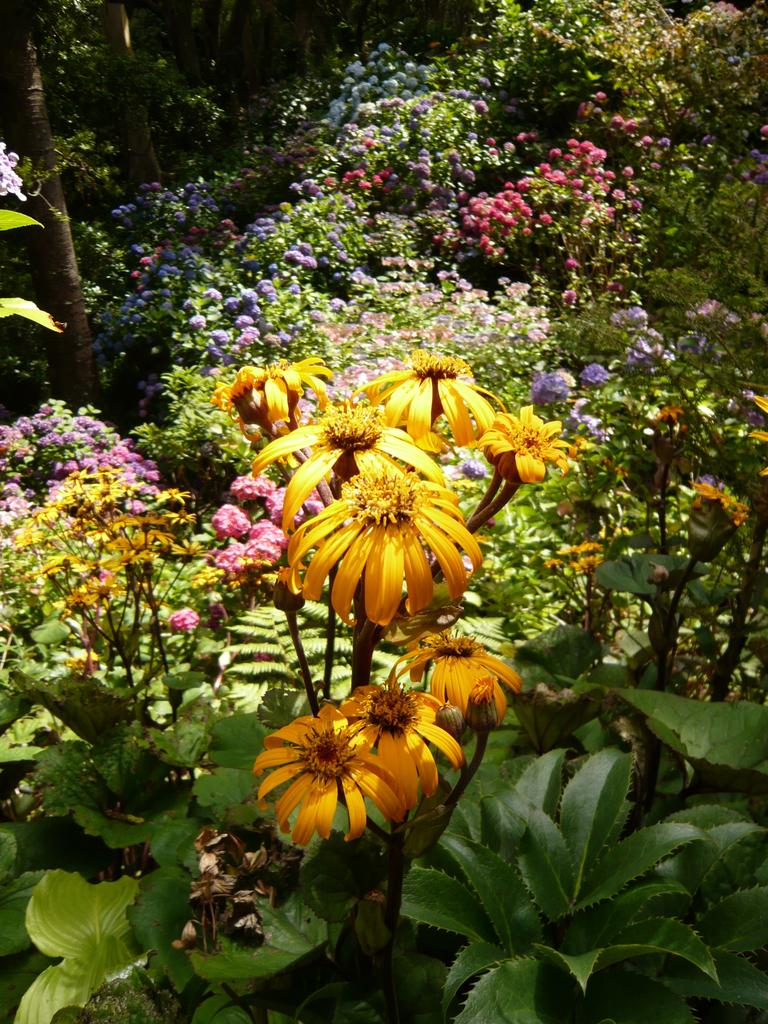What type of living organisms can be seen in the image? Plants can be seen in the image. Can you describe the flowers present in the image? There are flowers of different colors in the image. How many babies are present in the image? There are no babies present in the image; it features plants and flowers. What type of doll can be seen in the image? There is no doll present in the image. 